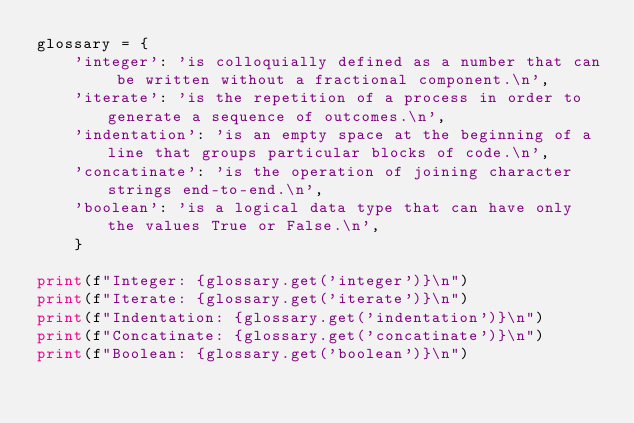Convert code to text. <code><loc_0><loc_0><loc_500><loc_500><_Python_>glossary = {
    'integer': 'is colloquially defined as a number that can be written without a fractional component.\n',
    'iterate': 'is the repetition of a process in order to generate a sequence of outcomes.\n',
    'indentation': 'is an empty space at the beginning of a line that groups particular blocks of code.\n',
    'concatinate': 'is the operation of joining character strings end-to-end.\n',
    'boolean': 'is a logical data type that can have only the values True or False.\n',
    }

print(f"Integer: {glossary.get('integer')}\n")
print(f"Iterate: {glossary.get('iterate')}\n")
print(f"Indentation: {glossary.get('indentation')}\n")
print(f"Concatinate: {glossary.get('concatinate')}\n")
print(f"Boolean: {glossary.get('boolean')}\n")
</code> 